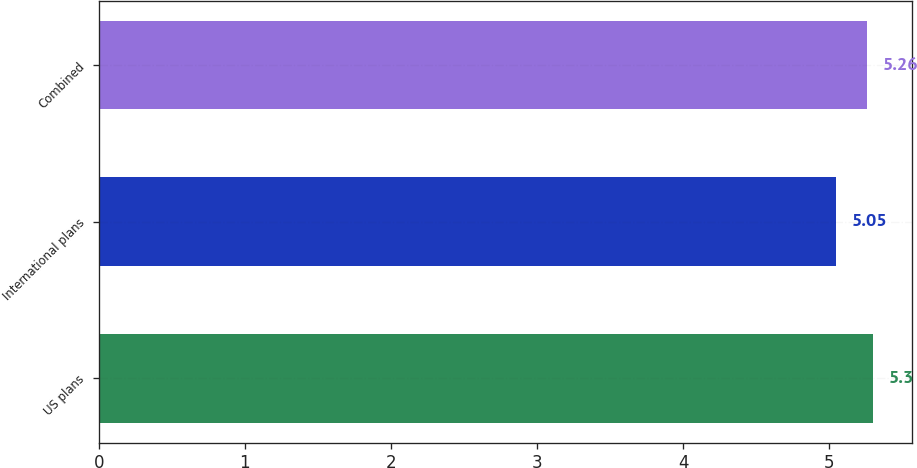<chart> <loc_0><loc_0><loc_500><loc_500><bar_chart><fcel>US plans<fcel>International plans<fcel>Combined<nl><fcel>5.3<fcel>5.05<fcel>5.26<nl></chart> 